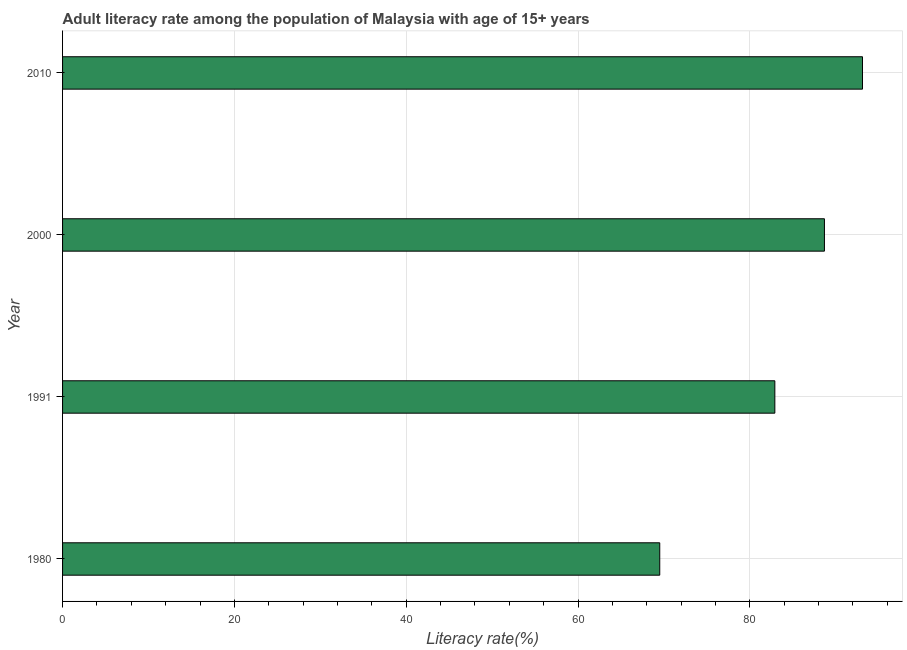What is the title of the graph?
Keep it short and to the point. Adult literacy rate among the population of Malaysia with age of 15+ years. What is the label or title of the X-axis?
Keep it short and to the point. Literacy rate(%). What is the label or title of the Y-axis?
Provide a short and direct response. Year. What is the adult literacy rate in 2010?
Give a very brief answer. 93.12. Across all years, what is the maximum adult literacy rate?
Your answer should be compact. 93.12. Across all years, what is the minimum adult literacy rate?
Provide a succinct answer. 69.52. In which year was the adult literacy rate minimum?
Give a very brief answer. 1980. What is the sum of the adult literacy rate?
Your answer should be compact. 334.24. What is the difference between the adult literacy rate in 1980 and 2010?
Keep it short and to the point. -23.6. What is the average adult literacy rate per year?
Give a very brief answer. 83.56. What is the median adult literacy rate?
Provide a succinct answer. 85.8. In how many years, is the adult literacy rate greater than 76 %?
Your answer should be very brief. 3. What is the ratio of the adult literacy rate in 1980 to that in 1991?
Make the answer very short. 0.84. Is the difference between the adult literacy rate in 1991 and 2000 greater than the difference between any two years?
Your answer should be compact. No. What is the difference between the highest and the second highest adult literacy rate?
Your answer should be compact. 4.43. What is the difference between the highest and the lowest adult literacy rate?
Your response must be concise. 23.6. How many bars are there?
Keep it short and to the point. 4. What is the difference between two consecutive major ticks on the X-axis?
Give a very brief answer. 20. Are the values on the major ticks of X-axis written in scientific E-notation?
Offer a very short reply. No. What is the Literacy rate(%) of 1980?
Your response must be concise. 69.52. What is the Literacy rate(%) of 1991?
Keep it short and to the point. 82.92. What is the Literacy rate(%) in 2000?
Keep it short and to the point. 88.69. What is the Literacy rate(%) in 2010?
Your answer should be very brief. 93.12. What is the difference between the Literacy rate(%) in 1980 and 1991?
Provide a short and direct response. -13.4. What is the difference between the Literacy rate(%) in 1980 and 2000?
Keep it short and to the point. -19.17. What is the difference between the Literacy rate(%) in 1980 and 2010?
Your response must be concise. -23.6. What is the difference between the Literacy rate(%) in 1991 and 2000?
Offer a terse response. -5.77. What is the difference between the Literacy rate(%) in 1991 and 2010?
Make the answer very short. -10.2. What is the difference between the Literacy rate(%) in 2000 and 2010?
Ensure brevity in your answer.  -4.43. What is the ratio of the Literacy rate(%) in 1980 to that in 1991?
Offer a terse response. 0.84. What is the ratio of the Literacy rate(%) in 1980 to that in 2000?
Ensure brevity in your answer.  0.78. What is the ratio of the Literacy rate(%) in 1980 to that in 2010?
Provide a short and direct response. 0.75. What is the ratio of the Literacy rate(%) in 1991 to that in 2000?
Keep it short and to the point. 0.94. What is the ratio of the Literacy rate(%) in 1991 to that in 2010?
Make the answer very short. 0.89. 